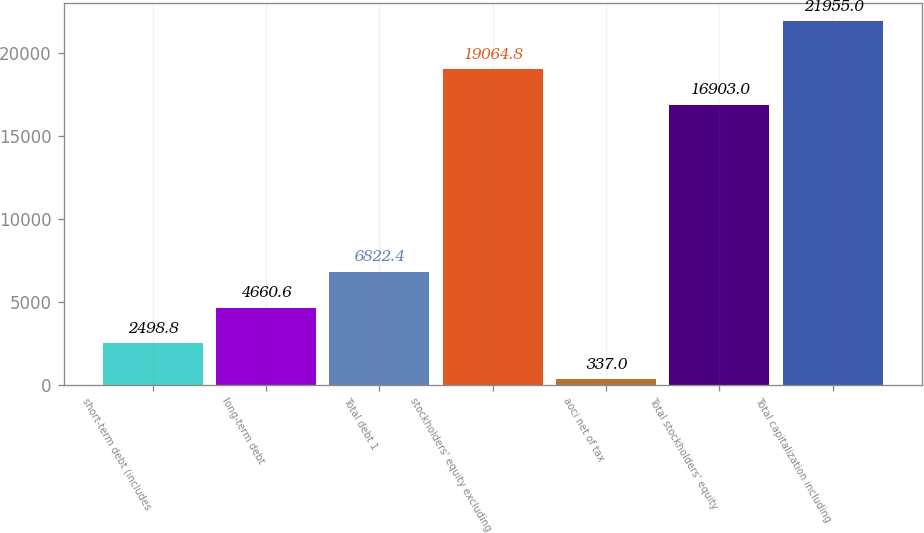Convert chart. <chart><loc_0><loc_0><loc_500><loc_500><bar_chart><fcel>short-term debt (includes<fcel>long-term debt<fcel>Total debt 1<fcel>stockholders' equity excluding<fcel>aoci net of tax<fcel>Total stockholders' equity<fcel>Total capitalization including<nl><fcel>2498.8<fcel>4660.6<fcel>6822.4<fcel>19064.8<fcel>337<fcel>16903<fcel>21955<nl></chart> 